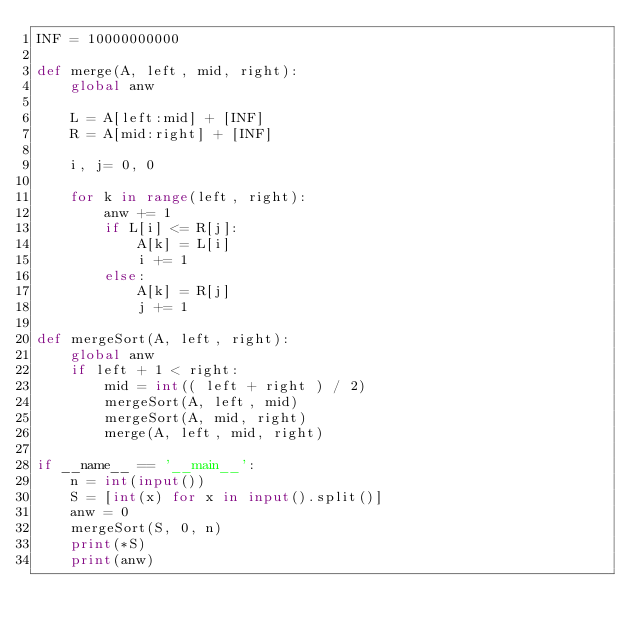<code> <loc_0><loc_0><loc_500><loc_500><_Python_>INF = 10000000000

def merge(A, left, mid, right):
    global anw

    L = A[left:mid] + [INF]
    R = A[mid:right] + [INF]

    i, j= 0, 0

    for k in range(left, right):
        anw += 1
        if L[i] <= R[j]:
            A[k] = L[i]
            i += 1
        else:
            A[k] = R[j]
            j += 1

def mergeSort(A, left, right):
    global anw
    if left + 1 < right:
        mid = int(( left + right ) / 2)
        mergeSort(A, left, mid)
        mergeSort(A, mid, right)
        merge(A, left, mid, right)

if __name__ == '__main__':
    n = int(input())
    S = [int(x) for x in input().split()]
    anw = 0
    mergeSort(S, 0, n)
    print(*S)
    print(anw)
</code> 